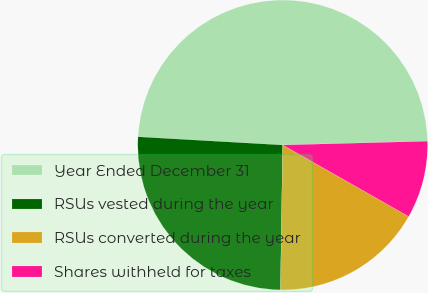Convert chart. <chart><loc_0><loc_0><loc_500><loc_500><pie_chart><fcel>Year Ended December 31<fcel>RSUs vested during the year<fcel>RSUs converted during the year<fcel>Shares withheld for taxes<nl><fcel>48.67%<fcel>25.66%<fcel>17.02%<fcel>8.64%<nl></chart> 